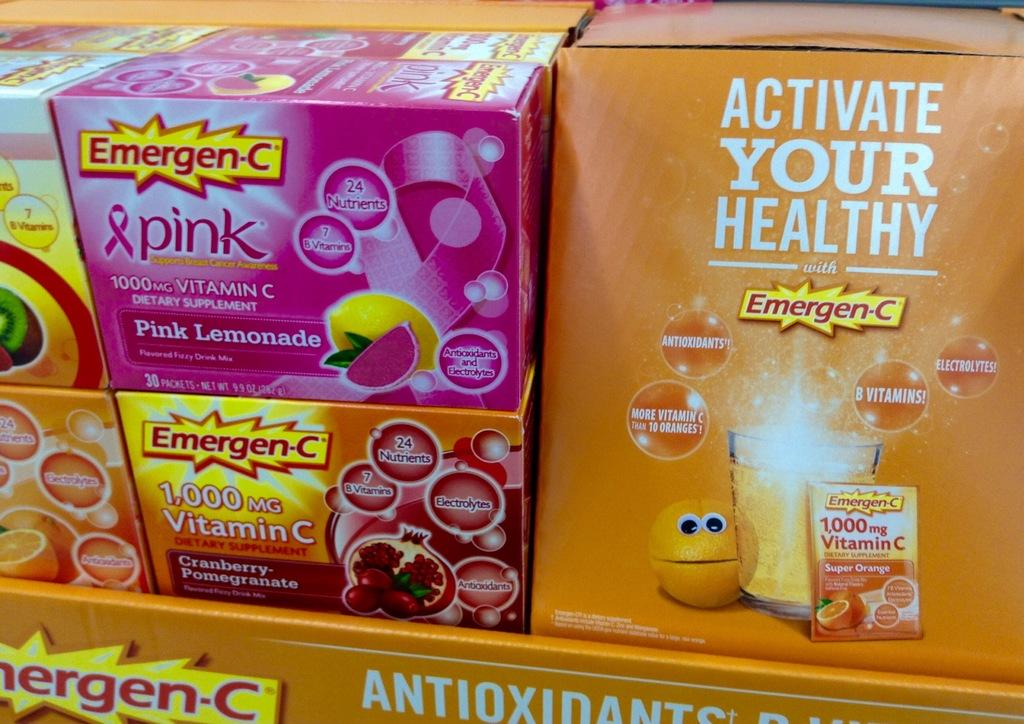What is present on the rack in the image? There are food packets on a rack in the image. Can you describe the arrangement of the food packets on the rack? The food packets are placed on the rack in an organized manner. What type of toothpaste is visible in the image? There is no toothpaste present in the image; it features food packets on a rack. How many tents are set up in the image? There are no tents present in the image; it features food packets on a rack. 